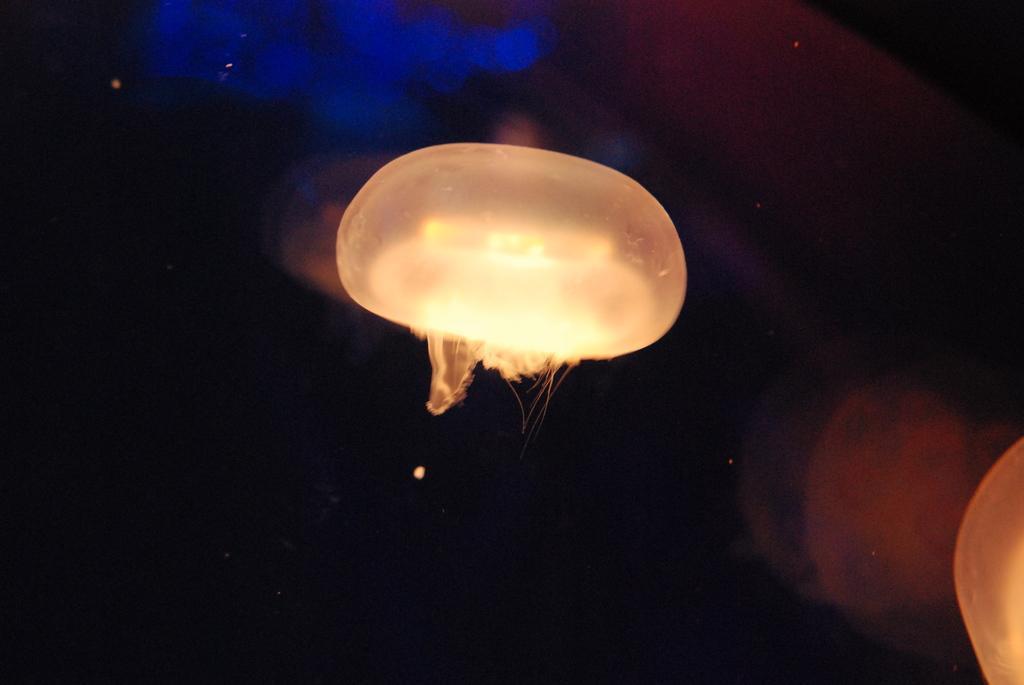Can you describe this image briefly? In this picture we can see lights and in the background it is dark. 